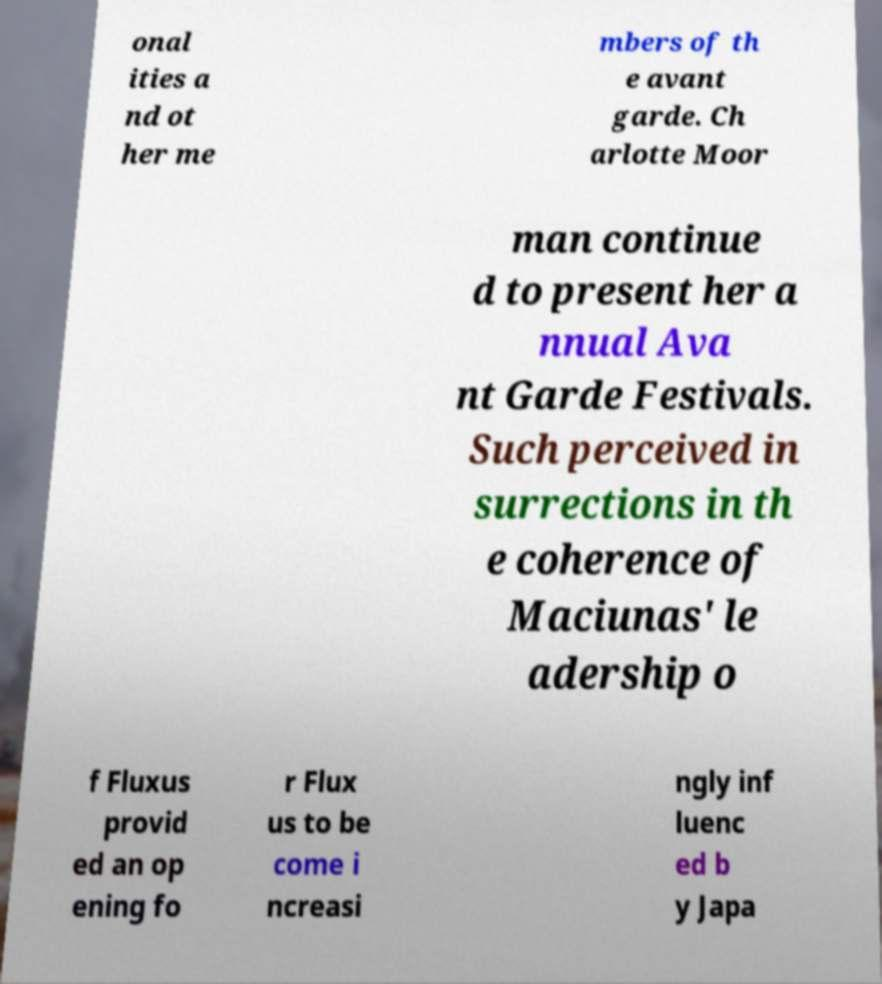Can you read and provide the text displayed in the image?This photo seems to have some interesting text. Can you extract and type it out for me? onal ities a nd ot her me mbers of th e avant garde. Ch arlotte Moor man continue d to present her a nnual Ava nt Garde Festivals. Such perceived in surrections in th e coherence of Maciunas' le adership o f Fluxus provid ed an op ening fo r Flux us to be come i ncreasi ngly inf luenc ed b y Japa 